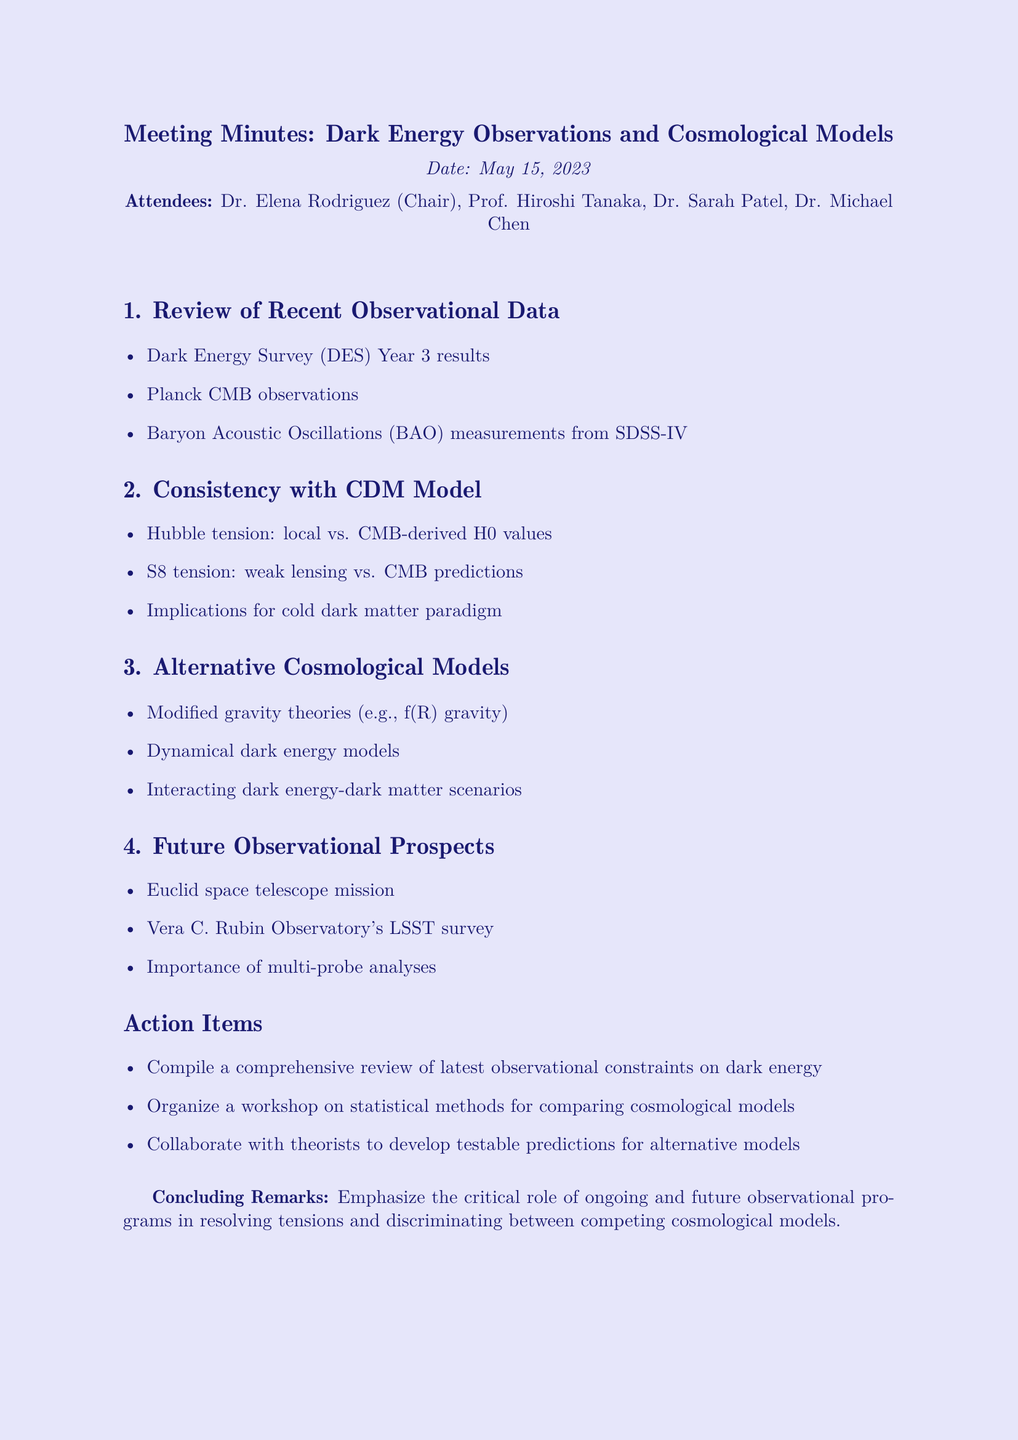What is the date of the meeting? The date of the meeting is explicitly mentioned in the document as May 15, 2023.
Answer: May 15, 2023 Who chaired the meeting? The document states that Dr. Elena Rodriguez served as the chair of the meeting.
Answer: Dr. Elena Rodriguez What observational survey results were reviewed? The agenda item specifically lists "Dark Energy Survey (DES) Year 3 results" among other observational data points.
Answer: Dark Energy Survey (DES) Year 3 results What is one of the alternative cosmological models discussed? The document lists "Modified gravity theories (e.g., f(R) gravity)" under alternative cosmological models, indicating it was discussed.
Answer: Modified gravity theories What is one action item from the meeting? The document includes "Compile a comprehensive review of latest observational constraints on dark energy" as an action item.
Answer: Compile a comprehensive review of latest observational constraints on dark energy What does the concluding remark emphasize? The concluding remarks highlight the importance of observational programs, indicating ongoing and future efforts are critical for resolving tensions.
Answer: Importance of ongoing and future observational programs Which two attendees are mentioned alongside Dr. Elena Rodriguez? The attending members listed in the document are Dr. Sarah Patel and Dr. Michael Chen, in addition to Dr. Elena Rodriguez.
Answer: Dr. Sarah Patel, Dr. Michael Chen What cosmological tension related to the ΛCDM model was discussed? The document mentions "Hubble tension: local vs. CMB-derived H0 values" as a topic under the consistency with ΛCDM model.
Answer: Hubble tension What is the title of the meeting? The title of the meeting is clearly stated at the beginning as "Dark Energy Observations and Cosmological Models: Interpreting the Evidence."
Answer: Dark Energy Observations and Cosmological Models: Interpreting the Evidence 